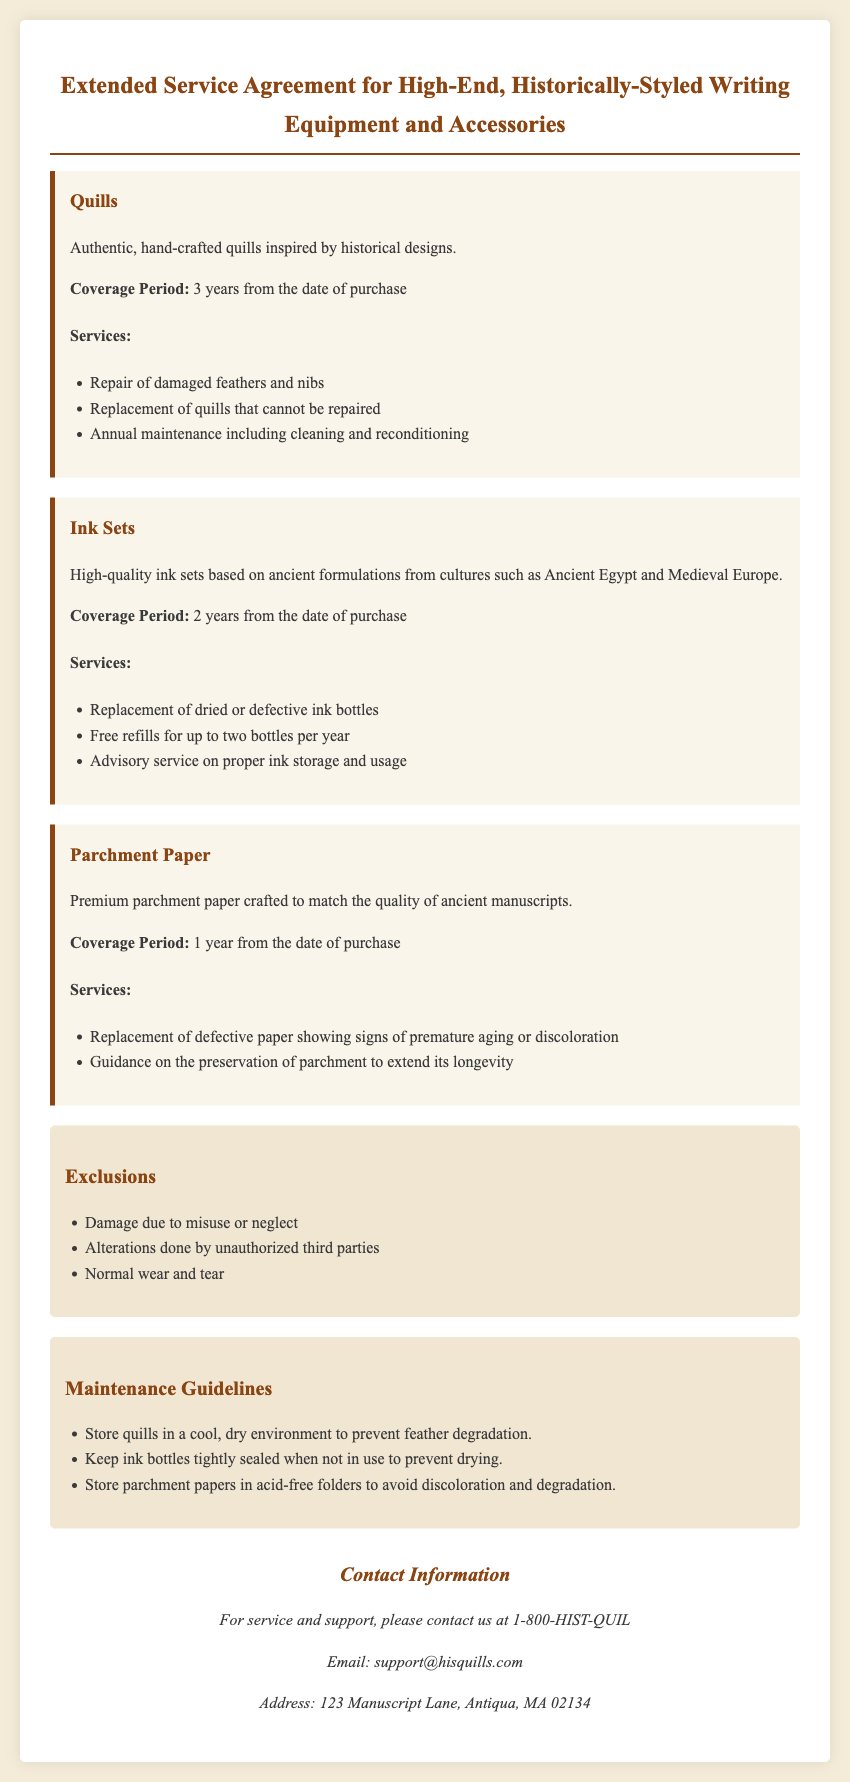What is the coverage period for quills? The coverage period for quills is stated as three years from the date of purchase.
Answer: 3 years What services are included for ink sets? The included services for ink sets are listed in a bullet format, and they include replacement, free refills, and advisory service.
Answer: Replacement of dried or defective ink bottles, free refills, advisory service What is the maximum refills allowed per year for ink bottles? The document specifies that users can have free refills for up to two bottles per year.
Answer: 2 bottles What is excluded from the warranty? The document outlines several exclusions, such as damage from misuse or alterations done by unauthorized parties.
Answer: Damage due to misuse or neglect What is the guidance provided for storing parchment? The document provides a maintenance guideline specifically for parchment storage, suggesting it should be kept in acid-free folders.
Answer: Acid-free folders What is the contact phone number for service and support? The contact information section lists the phone number for service and support that is provided in the document.
Answer: 1-800-HIST-QUIL How long is the coverage for parchment paper? The document specifies that the coverage period for parchment paper is one year from the date of purchase.
Answer: 1 year What type of ink formulations are used in the ink sets? The document mentions that the ink sets are based on ancient formulations from various cultures.
Answer: Ancient formulations What is a maintenance guideline for quills? The document includes a guideline that suggests storing quills in a cool, dry environment to prevent feather degradation.
Answer: Cool, dry environment 